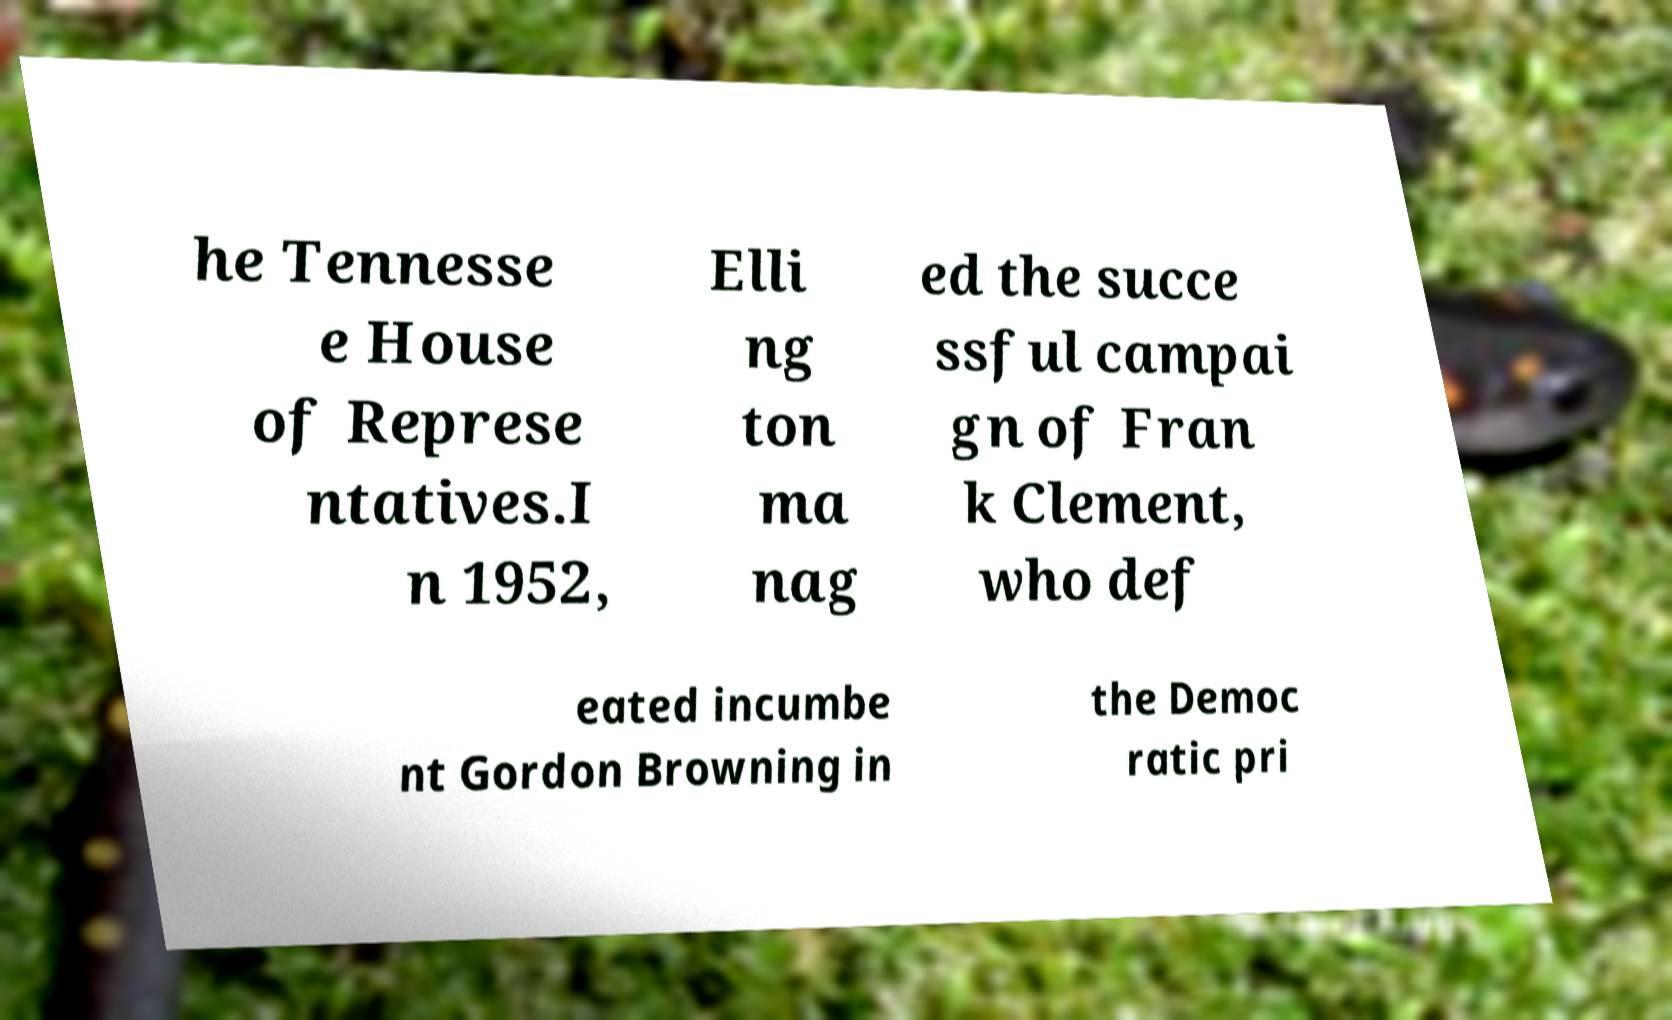Can you accurately transcribe the text from the provided image for me? he Tennesse e House of Represe ntatives.I n 1952, Elli ng ton ma nag ed the succe ssful campai gn of Fran k Clement, who def eated incumbe nt Gordon Browning in the Democ ratic pri 